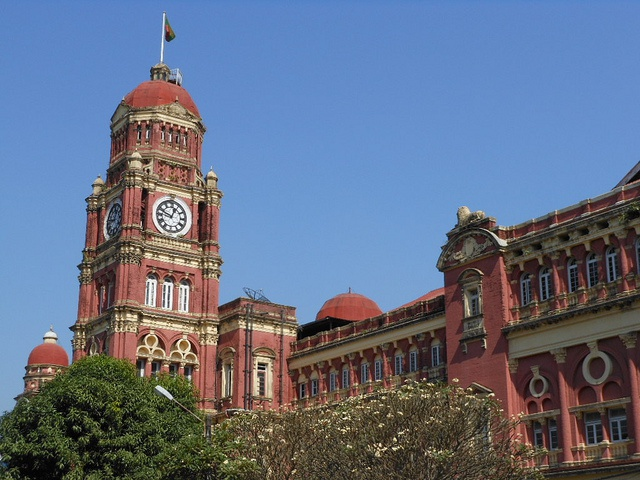Describe the objects in this image and their specific colors. I can see clock in gray, lightgray, darkgray, and black tones and clock in gray, black, and darkblue tones in this image. 